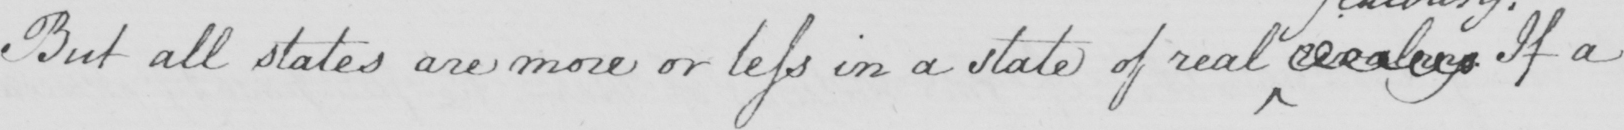Please transcribe the handwritten text in this image. But all states are more or less in a state of real  <gap/>   . If a 